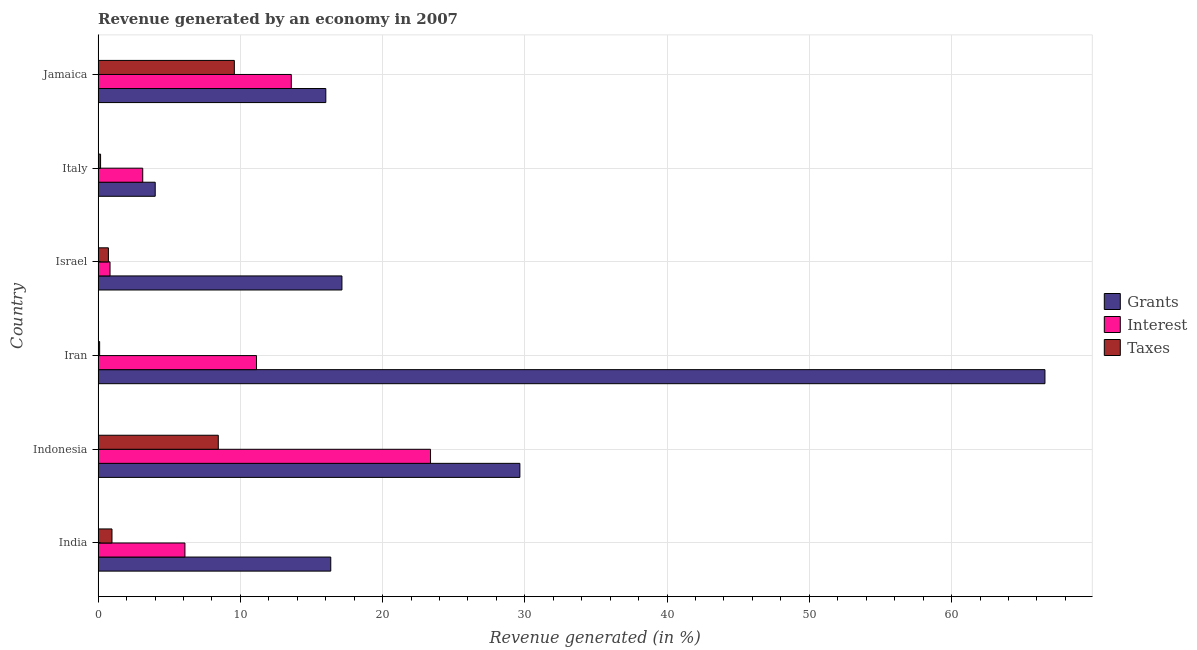How many bars are there on the 3rd tick from the top?
Your answer should be very brief. 3. How many bars are there on the 6th tick from the bottom?
Keep it short and to the point. 3. What is the label of the 5th group of bars from the top?
Offer a terse response. Indonesia. What is the percentage of revenue generated by interest in Iran?
Your answer should be very brief. 11.14. Across all countries, what is the maximum percentage of revenue generated by taxes?
Your response must be concise. 9.58. Across all countries, what is the minimum percentage of revenue generated by taxes?
Ensure brevity in your answer.  0.11. In which country was the percentage of revenue generated by grants maximum?
Give a very brief answer. Iran. In which country was the percentage of revenue generated by taxes minimum?
Offer a terse response. Iran. What is the total percentage of revenue generated by grants in the graph?
Your answer should be compact. 149.74. What is the difference between the percentage of revenue generated by grants in Indonesia and that in Jamaica?
Your answer should be compact. 13.64. What is the difference between the percentage of revenue generated by taxes in Jamaica and the percentage of revenue generated by interest in Italy?
Your response must be concise. 6.44. What is the average percentage of revenue generated by interest per country?
Keep it short and to the point. 9.69. What is the difference between the percentage of revenue generated by interest and percentage of revenue generated by taxes in India?
Offer a very short reply. 5.13. In how many countries, is the percentage of revenue generated by grants greater than 44 %?
Your answer should be compact. 1. What is the ratio of the percentage of revenue generated by taxes in Iran to that in Italy?
Keep it short and to the point. 0.61. Is the percentage of revenue generated by interest in Italy less than that in Jamaica?
Keep it short and to the point. Yes. Is the difference between the percentage of revenue generated by interest in Iran and Israel greater than the difference between the percentage of revenue generated by taxes in Iran and Israel?
Provide a short and direct response. Yes. What is the difference between the highest and the second highest percentage of revenue generated by grants?
Give a very brief answer. 36.91. What is the difference between the highest and the lowest percentage of revenue generated by grants?
Your answer should be compact. 62.55. Is the sum of the percentage of revenue generated by grants in India and Iran greater than the maximum percentage of revenue generated by interest across all countries?
Offer a terse response. Yes. What does the 3rd bar from the top in Iran represents?
Provide a short and direct response. Grants. What does the 1st bar from the bottom in Jamaica represents?
Ensure brevity in your answer.  Grants. Is it the case that in every country, the sum of the percentage of revenue generated by grants and percentage of revenue generated by interest is greater than the percentage of revenue generated by taxes?
Ensure brevity in your answer.  Yes. How many bars are there?
Provide a short and direct response. 18. How many legend labels are there?
Give a very brief answer. 3. What is the title of the graph?
Keep it short and to the point. Revenue generated by an economy in 2007. Does "Methane" appear as one of the legend labels in the graph?
Ensure brevity in your answer.  No. What is the label or title of the X-axis?
Ensure brevity in your answer.  Revenue generated (in %). What is the label or title of the Y-axis?
Ensure brevity in your answer.  Country. What is the Revenue generated (in %) in Grants in India?
Make the answer very short. 16.36. What is the Revenue generated (in %) of Interest in India?
Keep it short and to the point. 6.1. What is the Revenue generated (in %) in Taxes in India?
Offer a very short reply. 0.97. What is the Revenue generated (in %) in Grants in Indonesia?
Provide a short and direct response. 29.65. What is the Revenue generated (in %) in Interest in Indonesia?
Make the answer very short. 23.37. What is the Revenue generated (in %) of Taxes in Indonesia?
Your answer should be compact. 8.45. What is the Revenue generated (in %) of Grants in Iran?
Offer a very short reply. 66.57. What is the Revenue generated (in %) of Interest in Iran?
Provide a succinct answer. 11.14. What is the Revenue generated (in %) in Taxes in Iran?
Provide a short and direct response. 0.11. What is the Revenue generated (in %) in Grants in Israel?
Your answer should be very brief. 17.14. What is the Revenue generated (in %) in Interest in Israel?
Provide a succinct answer. 0.84. What is the Revenue generated (in %) of Taxes in Israel?
Provide a succinct answer. 0.72. What is the Revenue generated (in %) of Grants in Italy?
Give a very brief answer. 4.01. What is the Revenue generated (in %) of Interest in Italy?
Provide a short and direct response. 3.14. What is the Revenue generated (in %) in Taxes in Italy?
Give a very brief answer. 0.17. What is the Revenue generated (in %) of Grants in Jamaica?
Provide a short and direct response. 16.01. What is the Revenue generated (in %) of Interest in Jamaica?
Keep it short and to the point. 13.58. What is the Revenue generated (in %) in Taxes in Jamaica?
Offer a very short reply. 9.58. Across all countries, what is the maximum Revenue generated (in %) in Grants?
Your answer should be very brief. 66.57. Across all countries, what is the maximum Revenue generated (in %) in Interest?
Provide a short and direct response. 23.37. Across all countries, what is the maximum Revenue generated (in %) of Taxes?
Keep it short and to the point. 9.58. Across all countries, what is the minimum Revenue generated (in %) of Grants?
Provide a short and direct response. 4.01. Across all countries, what is the minimum Revenue generated (in %) of Interest?
Offer a terse response. 0.84. Across all countries, what is the minimum Revenue generated (in %) in Taxes?
Give a very brief answer. 0.11. What is the total Revenue generated (in %) of Grants in the graph?
Your answer should be very brief. 149.74. What is the total Revenue generated (in %) in Interest in the graph?
Ensure brevity in your answer.  58.17. What is the total Revenue generated (in %) in Taxes in the graph?
Ensure brevity in your answer.  20.01. What is the difference between the Revenue generated (in %) in Grants in India and that in Indonesia?
Make the answer very short. -13.29. What is the difference between the Revenue generated (in %) of Interest in India and that in Indonesia?
Ensure brevity in your answer.  -17.27. What is the difference between the Revenue generated (in %) of Taxes in India and that in Indonesia?
Make the answer very short. -7.47. What is the difference between the Revenue generated (in %) of Grants in India and that in Iran?
Give a very brief answer. -50.21. What is the difference between the Revenue generated (in %) of Interest in India and that in Iran?
Provide a succinct answer. -5.03. What is the difference between the Revenue generated (in %) of Taxes in India and that in Iran?
Offer a terse response. 0.87. What is the difference between the Revenue generated (in %) in Grants in India and that in Israel?
Your response must be concise. -0.79. What is the difference between the Revenue generated (in %) in Interest in India and that in Israel?
Your response must be concise. 5.27. What is the difference between the Revenue generated (in %) of Taxes in India and that in Israel?
Your answer should be compact. 0.25. What is the difference between the Revenue generated (in %) in Grants in India and that in Italy?
Provide a succinct answer. 12.34. What is the difference between the Revenue generated (in %) of Interest in India and that in Italy?
Your response must be concise. 2.97. What is the difference between the Revenue generated (in %) of Taxes in India and that in Italy?
Provide a succinct answer. 0.8. What is the difference between the Revenue generated (in %) in Grants in India and that in Jamaica?
Your response must be concise. 0.35. What is the difference between the Revenue generated (in %) in Interest in India and that in Jamaica?
Your answer should be compact. -7.48. What is the difference between the Revenue generated (in %) in Taxes in India and that in Jamaica?
Your answer should be compact. -8.6. What is the difference between the Revenue generated (in %) of Grants in Indonesia and that in Iran?
Offer a very short reply. -36.91. What is the difference between the Revenue generated (in %) in Interest in Indonesia and that in Iran?
Keep it short and to the point. 12.23. What is the difference between the Revenue generated (in %) of Taxes in Indonesia and that in Iran?
Offer a very short reply. 8.34. What is the difference between the Revenue generated (in %) of Grants in Indonesia and that in Israel?
Provide a short and direct response. 12.51. What is the difference between the Revenue generated (in %) in Interest in Indonesia and that in Israel?
Provide a succinct answer. 22.53. What is the difference between the Revenue generated (in %) of Taxes in Indonesia and that in Israel?
Your response must be concise. 7.73. What is the difference between the Revenue generated (in %) in Grants in Indonesia and that in Italy?
Make the answer very short. 25.64. What is the difference between the Revenue generated (in %) in Interest in Indonesia and that in Italy?
Ensure brevity in your answer.  20.23. What is the difference between the Revenue generated (in %) of Taxes in Indonesia and that in Italy?
Ensure brevity in your answer.  8.28. What is the difference between the Revenue generated (in %) in Grants in Indonesia and that in Jamaica?
Make the answer very short. 13.64. What is the difference between the Revenue generated (in %) in Interest in Indonesia and that in Jamaica?
Your response must be concise. 9.79. What is the difference between the Revenue generated (in %) of Taxes in Indonesia and that in Jamaica?
Keep it short and to the point. -1.13. What is the difference between the Revenue generated (in %) of Grants in Iran and that in Israel?
Make the answer very short. 49.42. What is the difference between the Revenue generated (in %) in Interest in Iran and that in Israel?
Ensure brevity in your answer.  10.3. What is the difference between the Revenue generated (in %) in Taxes in Iran and that in Israel?
Provide a succinct answer. -0.62. What is the difference between the Revenue generated (in %) in Grants in Iran and that in Italy?
Your answer should be compact. 62.55. What is the difference between the Revenue generated (in %) of Interest in Iran and that in Italy?
Provide a succinct answer. 8. What is the difference between the Revenue generated (in %) in Taxes in Iran and that in Italy?
Provide a short and direct response. -0.07. What is the difference between the Revenue generated (in %) of Grants in Iran and that in Jamaica?
Your answer should be very brief. 50.56. What is the difference between the Revenue generated (in %) of Interest in Iran and that in Jamaica?
Offer a very short reply. -2.44. What is the difference between the Revenue generated (in %) in Taxes in Iran and that in Jamaica?
Your answer should be compact. -9.47. What is the difference between the Revenue generated (in %) of Grants in Israel and that in Italy?
Provide a short and direct response. 13.13. What is the difference between the Revenue generated (in %) in Interest in Israel and that in Italy?
Give a very brief answer. -2.3. What is the difference between the Revenue generated (in %) in Taxes in Israel and that in Italy?
Give a very brief answer. 0.55. What is the difference between the Revenue generated (in %) in Grants in Israel and that in Jamaica?
Offer a very short reply. 1.13. What is the difference between the Revenue generated (in %) in Interest in Israel and that in Jamaica?
Give a very brief answer. -12.74. What is the difference between the Revenue generated (in %) of Taxes in Israel and that in Jamaica?
Provide a succinct answer. -8.85. What is the difference between the Revenue generated (in %) of Grants in Italy and that in Jamaica?
Keep it short and to the point. -11.99. What is the difference between the Revenue generated (in %) in Interest in Italy and that in Jamaica?
Your answer should be compact. -10.44. What is the difference between the Revenue generated (in %) of Taxes in Italy and that in Jamaica?
Offer a terse response. -9.4. What is the difference between the Revenue generated (in %) in Grants in India and the Revenue generated (in %) in Interest in Indonesia?
Keep it short and to the point. -7.01. What is the difference between the Revenue generated (in %) in Grants in India and the Revenue generated (in %) in Taxes in Indonesia?
Provide a succinct answer. 7.91. What is the difference between the Revenue generated (in %) of Interest in India and the Revenue generated (in %) of Taxes in Indonesia?
Offer a terse response. -2.35. What is the difference between the Revenue generated (in %) in Grants in India and the Revenue generated (in %) in Interest in Iran?
Your response must be concise. 5.22. What is the difference between the Revenue generated (in %) of Grants in India and the Revenue generated (in %) of Taxes in Iran?
Your response must be concise. 16.25. What is the difference between the Revenue generated (in %) in Interest in India and the Revenue generated (in %) in Taxes in Iran?
Your response must be concise. 6. What is the difference between the Revenue generated (in %) of Grants in India and the Revenue generated (in %) of Interest in Israel?
Ensure brevity in your answer.  15.52. What is the difference between the Revenue generated (in %) in Grants in India and the Revenue generated (in %) in Taxes in Israel?
Provide a short and direct response. 15.63. What is the difference between the Revenue generated (in %) in Interest in India and the Revenue generated (in %) in Taxes in Israel?
Ensure brevity in your answer.  5.38. What is the difference between the Revenue generated (in %) in Grants in India and the Revenue generated (in %) in Interest in Italy?
Offer a terse response. 13.22. What is the difference between the Revenue generated (in %) of Grants in India and the Revenue generated (in %) of Taxes in Italy?
Provide a succinct answer. 16.18. What is the difference between the Revenue generated (in %) in Interest in India and the Revenue generated (in %) in Taxes in Italy?
Provide a succinct answer. 5.93. What is the difference between the Revenue generated (in %) of Grants in India and the Revenue generated (in %) of Interest in Jamaica?
Give a very brief answer. 2.78. What is the difference between the Revenue generated (in %) in Grants in India and the Revenue generated (in %) in Taxes in Jamaica?
Your answer should be very brief. 6.78. What is the difference between the Revenue generated (in %) in Interest in India and the Revenue generated (in %) in Taxes in Jamaica?
Keep it short and to the point. -3.47. What is the difference between the Revenue generated (in %) of Grants in Indonesia and the Revenue generated (in %) of Interest in Iran?
Make the answer very short. 18.52. What is the difference between the Revenue generated (in %) in Grants in Indonesia and the Revenue generated (in %) in Taxes in Iran?
Give a very brief answer. 29.54. What is the difference between the Revenue generated (in %) in Interest in Indonesia and the Revenue generated (in %) in Taxes in Iran?
Make the answer very short. 23.26. What is the difference between the Revenue generated (in %) in Grants in Indonesia and the Revenue generated (in %) in Interest in Israel?
Provide a short and direct response. 28.81. What is the difference between the Revenue generated (in %) in Grants in Indonesia and the Revenue generated (in %) in Taxes in Israel?
Provide a succinct answer. 28.93. What is the difference between the Revenue generated (in %) of Interest in Indonesia and the Revenue generated (in %) of Taxes in Israel?
Provide a short and direct response. 22.65. What is the difference between the Revenue generated (in %) of Grants in Indonesia and the Revenue generated (in %) of Interest in Italy?
Ensure brevity in your answer.  26.51. What is the difference between the Revenue generated (in %) in Grants in Indonesia and the Revenue generated (in %) in Taxes in Italy?
Your answer should be very brief. 29.48. What is the difference between the Revenue generated (in %) in Interest in Indonesia and the Revenue generated (in %) in Taxes in Italy?
Give a very brief answer. 23.2. What is the difference between the Revenue generated (in %) of Grants in Indonesia and the Revenue generated (in %) of Interest in Jamaica?
Ensure brevity in your answer.  16.07. What is the difference between the Revenue generated (in %) of Grants in Indonesia and the Revenue generated (in %) of Taxes in Jamaica?
Your response must be concise. 20.07. What is the difference between the Revenue generated (in %) in Interest in Indonesia and the Revenue generated (in %) in Taxes in Jamaica?
Offer a terse response. 13.79. What is the difference between the Revenue generated (in %) in Grants in Iran and the Revenue generated (in %) in Interest in Israel?
Make the answer very short. 65.73. What is the difference between the Revenue generated (in %) in Grants in Iran and the Revenue generated (in %) in Taxes in Israel?
Your answer should be compact. 65.84. What is the difference between the Revenue generated (in %) of Interest in Iran and the Revenue generated (in %) of Taxes in Israel?
Offer a terse response. 10.41. What is the difference between the Revenue generated (in %) of Grants in Iran and the Revenue generated (in %) of Interest in Italy?
Your answer should be compact. 63.43. What is the difference between the Revenue generated (in %) of Grants in Iran and the Revenue generated (in %) of Taxes in Italy?
Your response must be concise. 66.39. What is the difference between the Revenue generated (in %) of Interest in Iran and the Revenue generated (in %) of Taxes in Italy?
Provide a succinct answer. 10.96. What is the difference between the Revenue generated (in %) of Grants in Iran and the Revenue generated (in %) of Interest in Jamaica?
Your response must be concise. 52.98. What is the difference between the Revenue generated (in %) of Grants in Iran and the Revenue generated (in %) of Taxes in Jamaica?
Provide a succinct answer. 56.99. What is the difference between the Revenue generated (in %) of Interest in Iran and the Revenue generated (in %) of Taxes in Jamaica?
Offer a terse response. 1.56. What is the difference between the Revenue generated (in %) in Grants in Israel and the Revenue generated (in %) in Interest in Italy?
Offer a terse response. 14.01. What is the difference between the Revenue generated (in %) of Grants in Israel and the Revenue generated (in %) of Taxes in Italy?
Offer a very short reply. 16.97. What is the difference between the Revenue generated (in %) in Interest in Israel and the Revenue generated (in %) in Taxes in Italy?
Offer a terse response. 0.66. What is the difference between the Revenue generated (in %) in Grants in Israel and the Revenue generated (in %) in Interest in Jamaica?
Your response must be concise. 3.56. What is the difference between the Revenue generated (in %) in Grants in Israel and the Revenue generated (in %) in Taxes in Jamaica?
Your response must be concise. 7.56. What is the difference between the Revenue generated (in %) in Interest in Israel and the Revenue generated (in %) in Taxes in Jamaica?
Offer a very short reply. -8.74. What is the difference between the Revenue generated (in %) of Grants in Italy and the Revenue generated (in %) of Interest in Jamaica?
Your answer should be compact. -9.57. What is the difference between the Revenue generated (in %) of Grants in Italy and the Revenue generated (in %) of Taxes in Jamaica?
Ensure brevity in your answer.  -5.56. What is the difference between the Revenue generated (in %) in Interest in Italy and the Revenue generated (in %) in Taxes in Jamaica?
Make the answer very short. -6.44. What is the average Revenue generated (in %) in Grants per country?
Offer a terse response. 24.96. What is the average Revenue generated (in %) in Interest per country?
Give a very brief answer. 9.69. What is the average Revenue generated (in %) in Taxes per country?
Provide a short and direct response. 3.33. What is the difference between the Revenue generated (in %) in Grants and Revenue generated (in %) in Interest in India?
Your response must be concise. 10.25. What is the difference between the Revenue generated (in %) in Grants and Revenue generated (in %) in Taxes in India?
Your answer should be very brief. 15.38. What is the difference between the Revenue generated (in %) in Interest and Revenue generated (in %) in Taxes in India?
Give a very brief answer. 5.13. What is the difference between the Revenue generated (in %) of Grants and Revenue generated (in %) of Interest in Indonesia?
Ensure brevity in your answer.  6.28. What is the difference between the Revenue generated (in %) in Grants and Revenue generated (in %) in Taxes in Indonesia?
Give a very brief answer. 21.2. What is the difference between the Revenue generated (in %) of Interest and Revenue generated (in %) of Taxes in Indonesia?
Your answer should be very brief. 14.92. What is the difference between the Revenue generated (in %) of Grants and Revenue generated (in %) of Interest in Iran?
Your answer should be compact. 55.43. What is the difference between the Revenue generated (in %) in Grants and Revenue generated (in %) in Taxes in Iran?
Offer a very short reply. 66.46. What is the difference between the Revenue generated (in %) in Interest and Revenue generated (in %) in Taxes in Iran?
Provide a succinct answer. 11.03. What is the difference between the Revenue generated (in %) in Grants and Revenue generated (in %) in Interest in Israel?
Give a very brief answer. 16.3. What is the difference between the Revenue generated (in %) in Grants and Revenue generated (in %) in Taxes in Israel?
Give a very brief answer. 16.42. What is the difference between the Revenue generated (in %) in Interest and Revenue generated (in %) in Taxes in Israel?
Your answer should be very brief. 0.11. What is the difference between the Revenue generated (in %) in Grants and Revenue generated (in %) in Interest in Italy?
Your response must be concise. 0.88. What is the difference between the Revenue generated (in %) in Grants and Revenue generated (in %) in Taxes in Italy?
Make the answer very short. 3.84. What is the difference between the Revenue generated (in %) of Interest and Revenue generated (in %) of Taxes in Italy?
Offer a very short reply. 2.96. What is the difference between the Revenue generated (in %) of Grants and Revenue generated (in %) of Interest in Jamaica?
Provide a succinct answer. 2.43. What is the difference between the Revenue generated (in %) in Grants and Revenue generated (in %) in Taxes in Jamaica?
Ensure brevity in your answer.  6.43. What is the difference between the Revenue generated (in %) in Interest and Revenue generated (in %) in Taxes in Jamaica?
Give a very brief answer. 4. What is the ratio of the Revenue generated (in %) in Grants in India to that in Indonesia?
Ensure brevity in your answer.  0.55. What is the ratio of the Revenue generated (in %) of Interest in India to that in Indonesia?
Provide a short and direct response. 0.26. What is the ratio of the Revenue generated (in %) of Taxes in India to that in Indonesia?
Your answer should be compact. 0.12. What is the ratio of the Revenue generated (in %) in Grants in India to that in Iran?
Give a very brief answer. 0.25. What is the ratio of the Revenue generated (in %) in Interest in India to that in Iran?
Your response must be concise. 0.55. What is the ratio of the Revenue generated (in %) of Taxes in India to that in Iran?
Give a very brief answer. 9.14. What is the ratio of the Revenue generated (in %) in Grants in India to that in Israel?
Keep it short and to the point. 0.95. What is the ratio of the Revenue generated (in %) of Interest in India to that in Israel?
Your answer should be very brief. 7.29. What is the ratio of the Revenue generated (in %) of Taxes in India to that in Israel?
Keep it short and to the point. 1.35. What is the ratio of the Revenue generated (in %) in Grants in India to that in Italy?
Offer a terse response. 4.07. What is the ratio of the Revenue generated (in %) in Interest in India to that in Italy?
Offer a terse response. 1.95. What is the ratio of the Revenue generated (in %) in Taxes in India to that in Italy?
Make the answer very short. 5.62. What is the ratio of the Revenue generated (in %) of Grants in India to that in Jamaica?
Provide a succinct answer. 1.02. What is the ratio of the Revenue generated (in %) of Interest in India to that in Jamaica?
Keep it short and to the point. 0.45. What is the ratio of the Revenue generated (in %) in Taxes in India to that in Jamaica?
Your response must be concise. 0.1. What is the ratio of the Revenue generated (in %) in Grants in Indonesia to that in Iran?
Provide a succinct answer. 0.45. What is the ratio of the Revenue generated (in %) in Interest in Indonesia to that in Iran?
Keep it short and to the point. 2.1. What is the ratio of the Revenue generated (in %) in Taxes in Indonesia to that in Iran?
Provide a succinct answer. 79.2. What is the ratio of the Revenue generated (in %) of Grants in Indonesia to that in Israel?
Offer a terse response. 1.73. What is the ratio of the Revenue generated (in %) in Interest in Indonesia to that in Israel?
Your response must be concise. 27.92. What is the ratio of the Revenue generated (in %) in Taxes in Indonesia to that in Israel?
Your answer should be compact. 11.68. What is the ratio of the Revenue generated (in %) of Grants in Indonesia to that in Italy?
Offer a very short reply. 7.39. What is the ratio of the Revenue generated (in %) in Interest in Indonesia to that in Italy?
Your answer should be compact. 7.45. What is the ratio of the Revenue generated (in %) of Taxes in Indonesia to that in Italy?
Offer a terse response. 48.7. What is the ratio of the Revenue generated (in %) in Grants in Indonesia to that in Jamaica?
Ensure brevity in your answer.  1.85. What is the ratio of the Revenue generated (in %) of Interest in Indonesia to that in Jamaica?
Keep it short and to the point. 1.72. What is the ratio of the Revenue generated (in %) of Taxes in Indonesia to that in Jamaica?
Your answer should be compact. 0.88. What is the ratio of the Revenue generated (in %) in Grants in Iran to that in Israel?
Provide a succinct answer. 3.88. What is the ratio of the Revenue generated (in %) of Interest in Iran to that in Israel?
Ensure brevity in your answer.  13.3. What is the ratio of the Revenue generated (in %) of Taxes in Iran to that in Israel?
Provide a succinct answer. 0.15. What is the ratio of the Revenue generated (in %) of Grants in Iran to that in Italy?
Your answer should be compact. 16.58. What is the ratio of the Revenue generated (in %) in Interest in Iran to that in Italy?
Give a very brief answer. 3.55. What is the ratio of the Revenue generated (in %) of Taxes in Iran to that in Italy?
Ensure brevity in your answer.  0.61. What is the ratio of the Revenue generated (in %) of Grants in Iran to that in Jamaica?
Give a very brief answer. 4.16. What is the ratio of the Revenue generated (in %) in Interest in Iran to that in Jamaica?
Your answer should be compact. 0.82. What is the ratio of the Revenue generated (in %) in Taxes in Iran to that in Jamaica?
Ensure brevity in your answer.  0.01. What is the ratio of the Revenue generated (in %) of Grants in Israel to that in Italy?
Your answer should be compact. 4.27. What is the ratio of the Revenue generated (in %) of Interest in Israel to that in Italy?
Offer a terse response. 0.27. What is the ratio of the Revenue generated (in %) of Taxes in Israel to that in Italy?
Make the answer very short. 4.17. What is the ratio of the Revenue generated (in %) of Grants in Israel to that in Jamaica?
Your answer should be compact. 1.07. What is the ratio of the Revenue generated (in %) in Interest in Israel to that in Jamaica?
Your response must be concise. 0.06. What is the ratio of the Revenue generated (in %) of Taxes in Israel to that in Jamaica?
Your answer should be very brief. 0.08. What is the ratio of the Revenue generated (in %) in Grants in Italy to that in Jamaica?
Provide a succinct answer. 0.25. What is the ratio of the Revenue generated (in %) in Interest in Italy to that in Jamaica?
Your response must be concise. 0.23. What is the ratio of the Revenue generated (in %) in Taxes in Italy to that in Jamaica?
Your answer should be compact. 0.02. What is the difference between the highest and the second highest Revenue generated (in %) of Grants?
Give a very brief answer. 36.91. What is the difference between the highest and the second highest Revenue generated (in %) in Interest?
Give a very brief answer. 9.79. What is the difference between the highest and the second highest Revenue generated (in %) of Taxes?
Provide a short and direct response. 1.13. What is the difference between the highest and the lowest Revenue generated (in %) in Grants?
Your answer should be very brief. 62.55. What is the difference between the highest and the lowest Revenue generated (in %) of Interest?
Your response must be concise. 22.53. What is the difference between the highest and the lowest Revenue generated (in %) in Taxes?
Your answer should be compact. 9.47. 